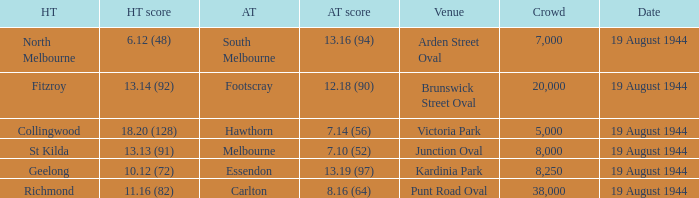What is Fitzroy's Home team score? 13.14 (92). 